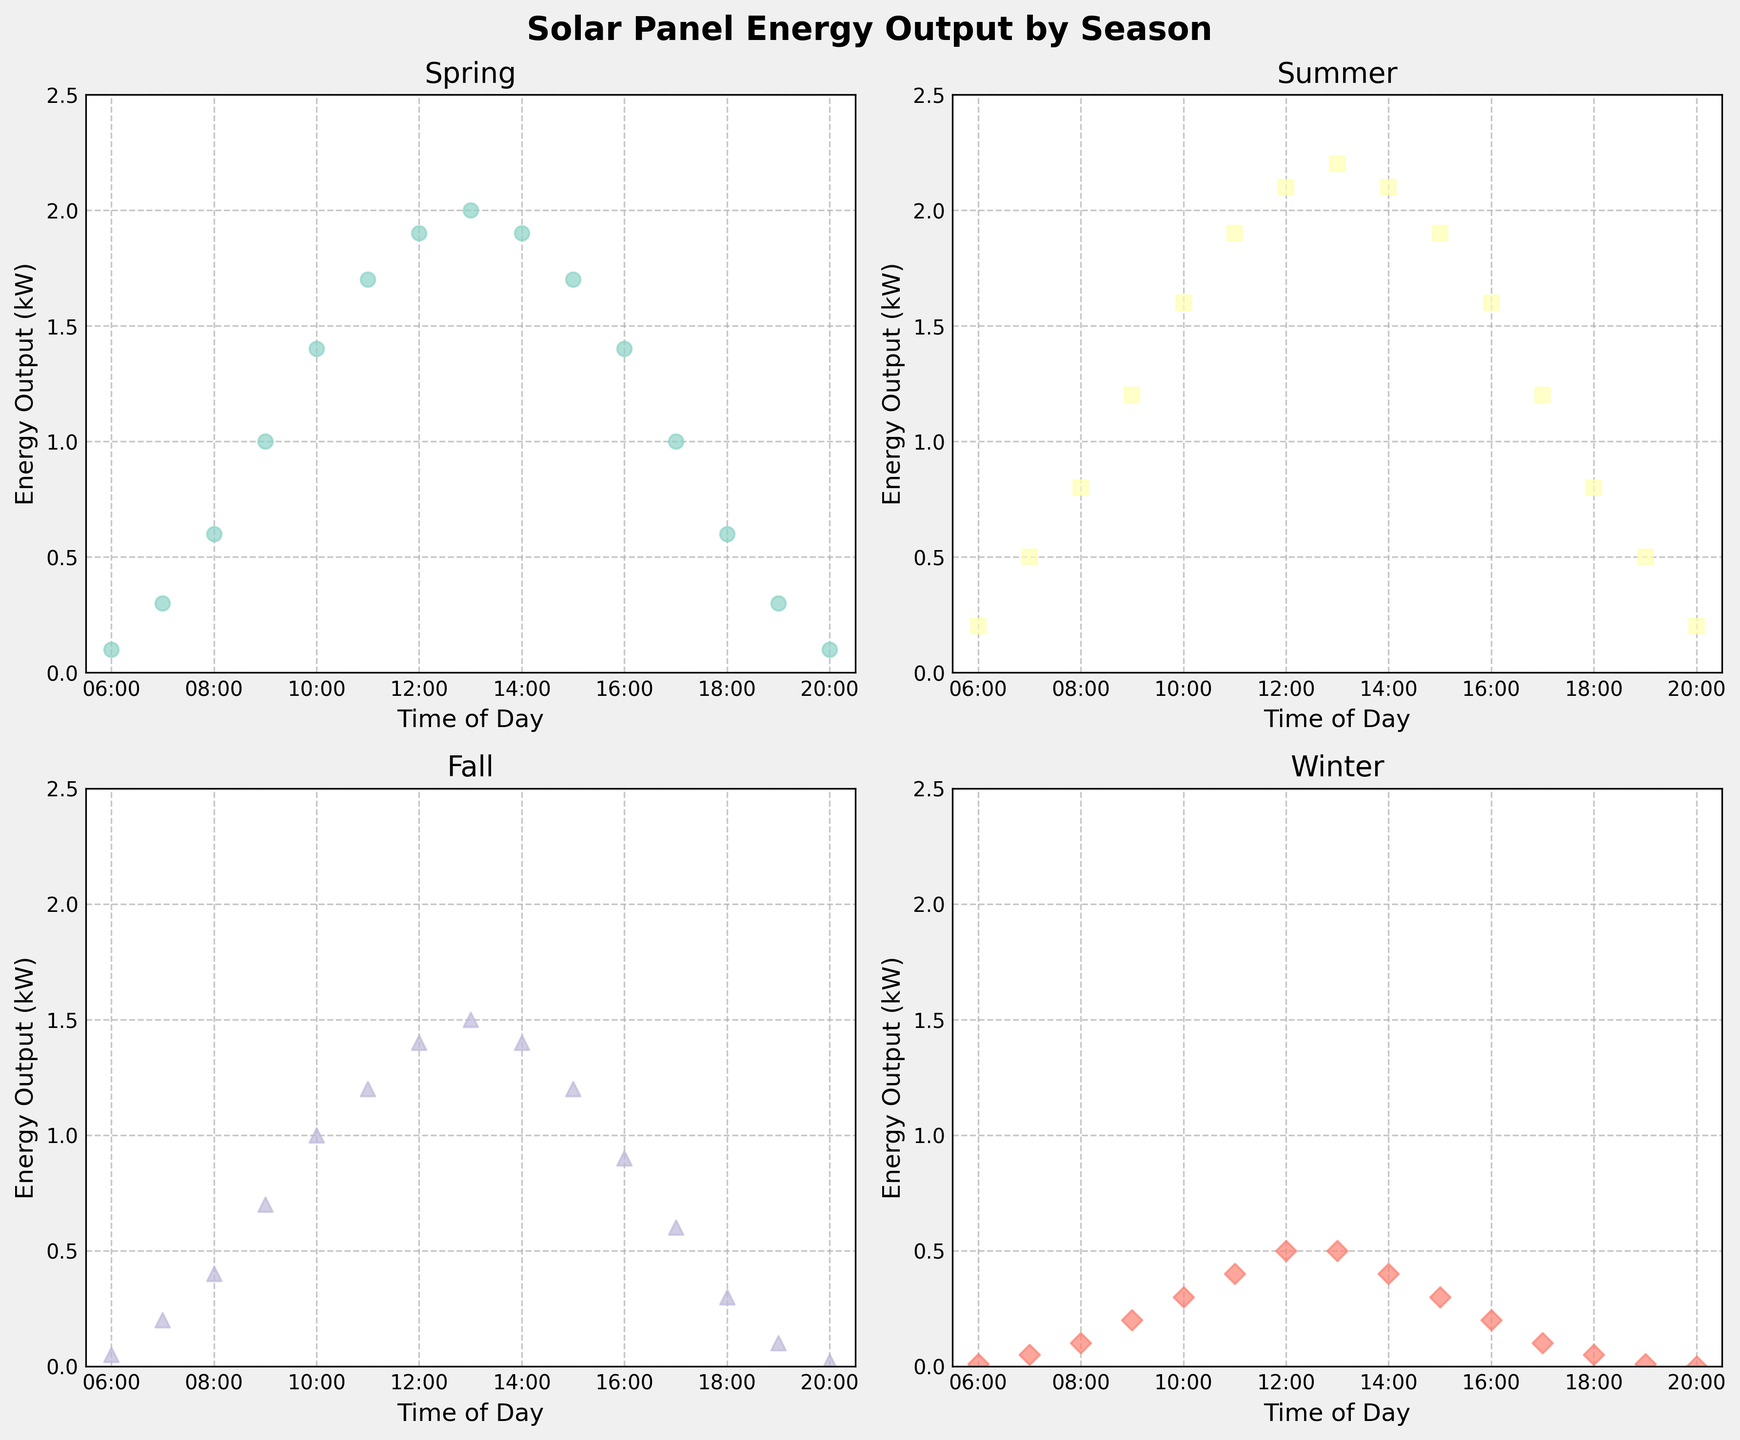What's the energy output at 10:00 AM during Spring? To find the energy output at 10:00 AM during Spring, locate the marker for 10:00 on the x-axis in the Spring subplot, then refer to its position on the y-axis.
Answer: 1.4 kW Which season has the highest energy output at 12:00 PM? Check the energy output data points for 12:00 PM across all four subplots and compare them. Summer has the highest output.
Answer: Summer Between 9:00 AM and 3:00 PM, which season experiences the largest decrease in energy output? Calculate the difference in energy output between 9:00 AM and 3:00 PM for each season by referring to the figure: Spring (1.0 to 1.7), Summer (1.2 to 1.9), Fall (0.7 to 1.2), Winter (0.2 to 0.3).
Answer: Spring What is the difference in energy output at 3:00 PM between Summer and Winter? Locate the 3:00 PM marker for both Summer and Winter subplots, then subtract Winter's value from Summer's: 1.9 - 0.3 = 1.6 kW.
Answer: 1.6 kW Does any season show an energy output of exactly 2.0 kW? If so, at what time? Look for data points touching or crossing 2.0 kW in all subplots. Only Summer shows such an output at 1:00 PM.
Answer: Yes, Summer at 1:00 PM For how many hours does Winter have a higher energy output than 0.1 kW? Identify the hours in the Winter subplot where the energy output is above 0.1 kW. These hours are 8:00 AM to 4:00 PM.
Answer: 8 hours Which season has the steepest energy output increase between 6:00 AM and 8:00 AM? Check the rise in energy output between 6:00 AM and 8:00 AM for each season: Spring (0.1 to 0.6), Summer (0.2 to 0.8), Fall (0.05 to 0.4), Winter (0.01 to 0.1). The steepest increase is in Summer.
Answer: Summer 